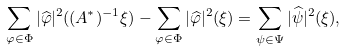<formula> <loc_0><loc_0><loc_500><loc_500>\sum _ { \varphi \in \Phi } | \widehat { \varphi } | ^ { 2 } ( ( A ^ { * } ) ^ { - 1 } \xi ) - \sum _ { \varphi \in \Phi } | \widehat { \varphi } | ^ { 2 } ( \xi ) = \sum _ { \psi \in \Psi } | \widehat { \psi } | ^ { 2 } ( \xi ) ,</formula> 